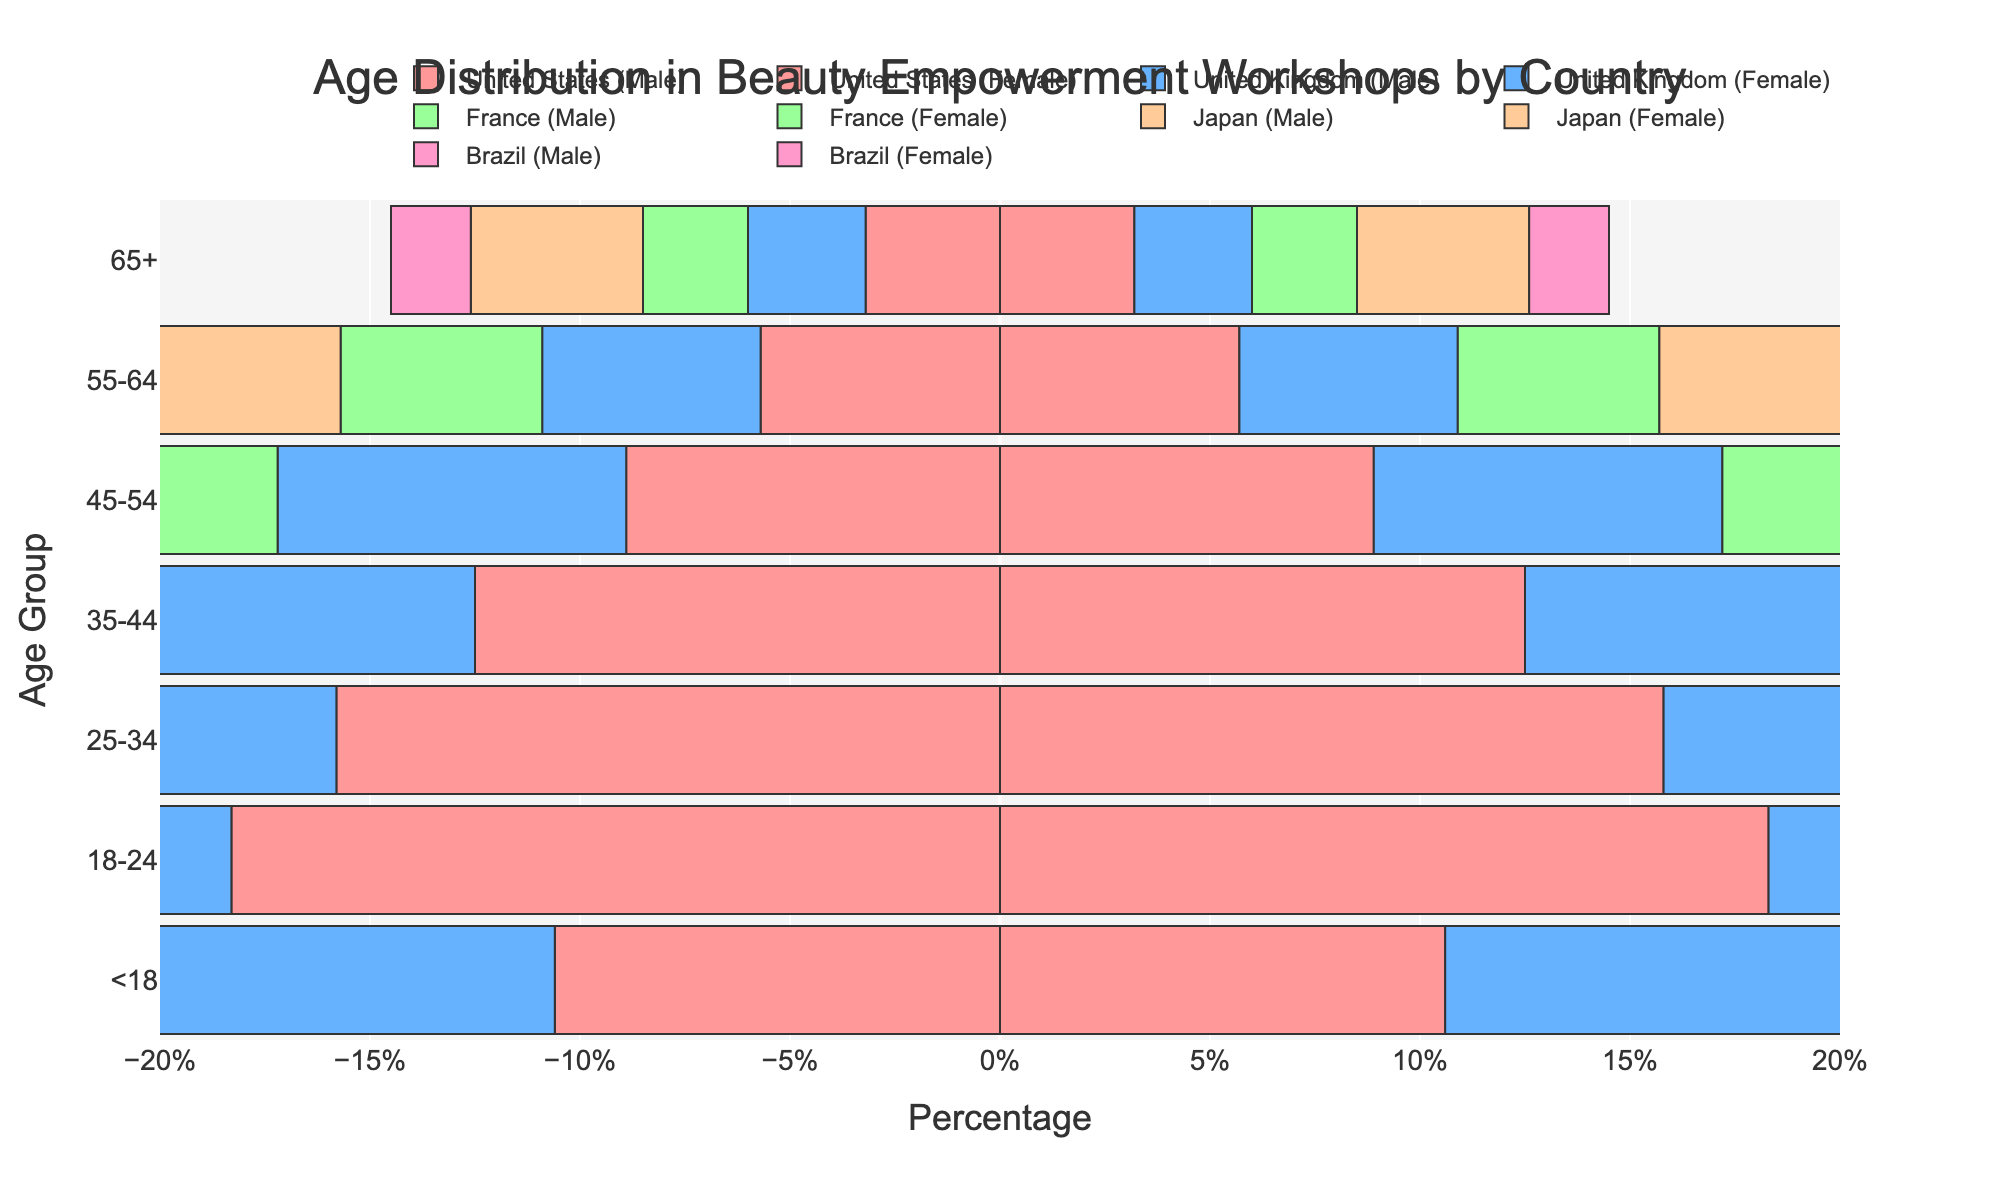What age group in Brazil has the highest participation in beauty empowerment workshops? According to the data for Brazil, the age group 18-24 has the highest percentage of participation at 17.9%.
Answer: 18-24 Which country has the lowest participation in the 65+ age group? The data shows that Brazil has the lowest participation in the 65+ age group with 1.9%.
Answer: Brazil Compare the participation of the age group 35-44 in the United States and Japan. Which country has more participants? The participation percentage of the age group 35-44 in the United States is 12.5%, whereas in Japan it is 11.8%. Therefore, the United States has more participants in this age group.
Answer: United States What is the total percentage of participants below 25 years old in France? Sum the percentages of age groups <18 and 18-24 in France: 9.1% (for <18) + 16.8% (for 18-24) = 25.9%.
Answer: 25.9% Which age group in Japan has nearly the same level of participation as the age group 45-54 in Brazil? The 45-54 age group in Brazil stands at 6.8%. In Japan, the closest percentage is the same age group (45-54) with 9.2%, which is still significantly higher. Therefore, no exact match but this is the closest.
Answer: None exactly matches; 45-54 in Japan is closest What is the difference in participation between the 25-34 age group and the 65+ age group in the United Kingdom? Subtract the percentage of the 65+ age group from the 25-34 age group in the United Kingdom: 14.9% (for 25-34) - 2.8% (for 65+) = 12.1%.
Answer: 12.1% How does the participation in the 55-64 age group in Brazil compare to the same age group in the United States? The participation in the 55-64 age group in Brazil is 3.5%, while in the United States it is 5.7%. The United States has a higher participation in this age group compared to Brazil.
Answer: United States has higher participation Which country shows the highest participation in the 18-24 age group? The data shows that the United States has the highest participation in the 18-24 age group at 18.3%.
Answer: United States What is the participation rate for the age group under 18 in the United Kingdom? The participation rate for the age group under 18 in the United Kingdom is 9.8%.
Answer: 9.8% Is there any age group where all five countries have participation rates over 10%? Look at each age group: for 18-24, all five countries have rates above 10% (United States 18.3%, United Kingdom 17.6%, France 16.8%, Japan 15.2%, Brazil 17.9%).
Answer: 18-24 